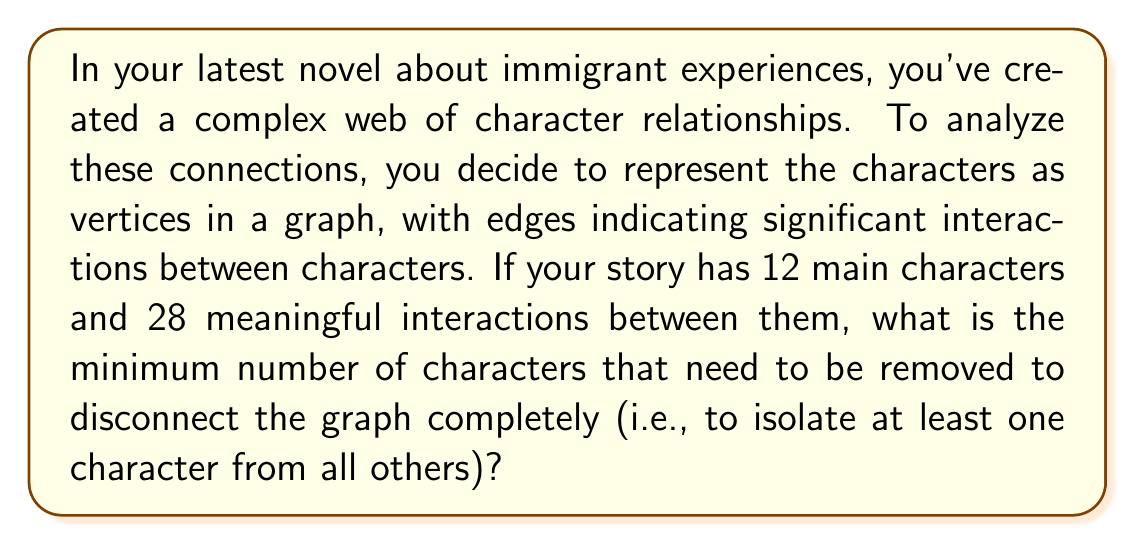What is the answer to this math problem? To solve this problem, we need to understand the concept of vertex connectivity in graph theory. The vertex connectivity of a graph, denoted as $\kappa(G)$, is the minimum number of vertices that need to be removed to disconnect the graph.

Let's approach this step-by-step:

1) First, we need to consider the maximum possible vertex connectivity for a graph with 12 vertices. In a complete graph with $n$ vertices, the vertex connectivity is $n-1$. However, our graph is not complete.

2) We can use a theorem that relates the minimum degree $\delta(G)$, edge connectivity $\lambda(G)$, and vertex connectivity $\kappa(G)$ of a graph:

   $$\kappa(G) \leq \lambda(G) \leq \delta(G)$$

3) In our case, we have 12 vertices and 28 edges. The average degree of a vertex is:

   $$\frac{2|E|}{|V|} = \frac{2 \cdot 28}{12} = \frac{14}{3} \approx 4.67$$

4) Since the average degree is less than 5, there must be at least one vertex with degree 4 or less. Therefore, $\delta(G) \leq 4$.

5) From the inequality in step 2, we can conclude that $\kappa(G) \leq 4$.

6) However, we need to consider if it's possible to disconnect the graph with fewer than 4 vertex removals. Given the number of edges and vertices, it's unlikely that removing 1 or 2 vertices would disconnect the graph.

7) Without more specific information about the graph structure, we can't determine if 3 vertex removals would be sufficient. Therefore, the safest answer is 4.

This analysis reflects the complexity of character relationships in your novel, where removing a few key characters could potentially fragment the entire narrative structure.
Answer: 4 